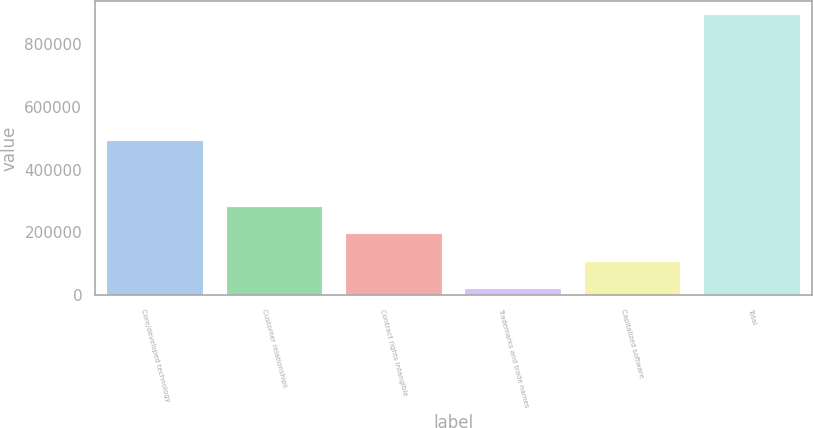<chart> <loc_0><loc_0><loc_500><loc_500><bar_chart><fcel>Core/developed technology<fcel>Customer relationships<fcel>Contract rights intangible<fcel>Trademarks and trade names<fcel>Capitalized software<fcel>Total<nl><fcel>490242<fcel>281046<fcel>193624<fcel>18779<fcel>106201<fcel>893002<nl></chart> 